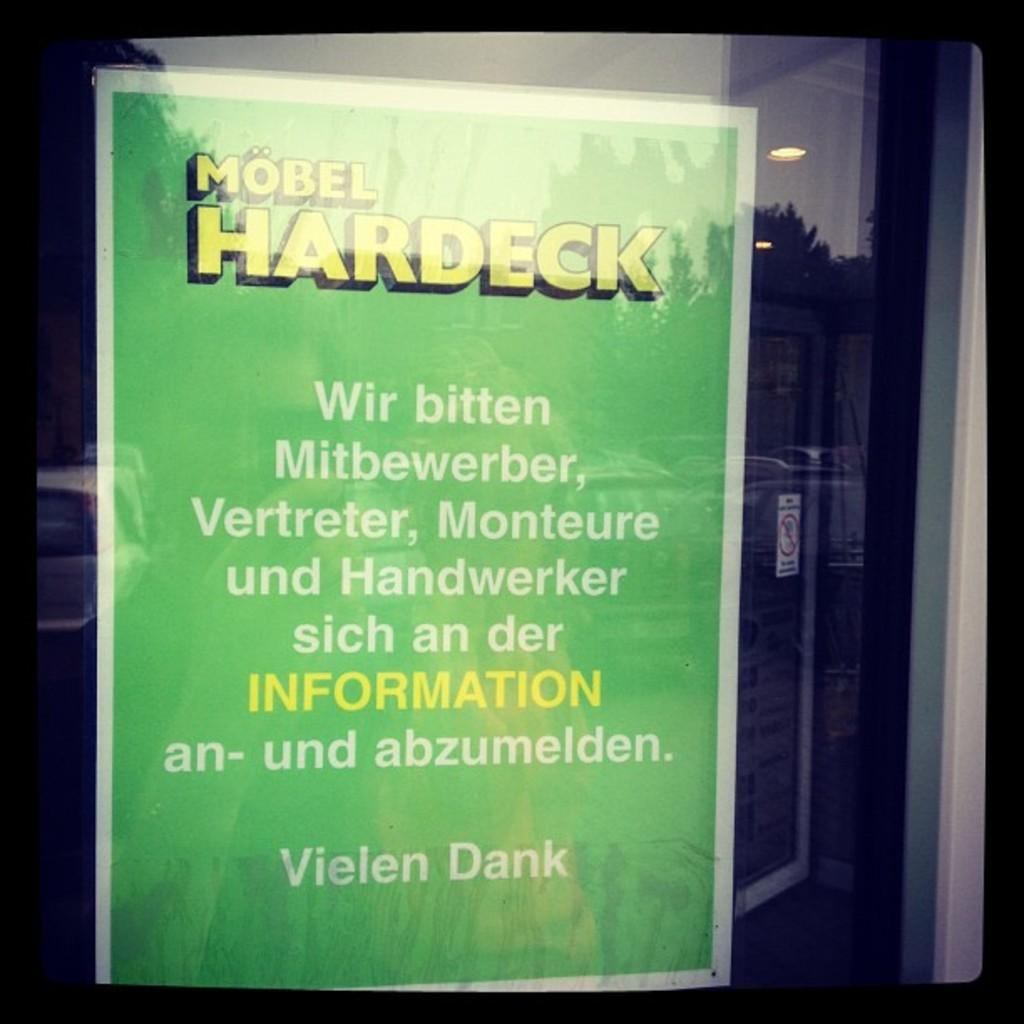<image>
Summarize the visual content of the image. A green sign with INFORMATION hangs on a store window 